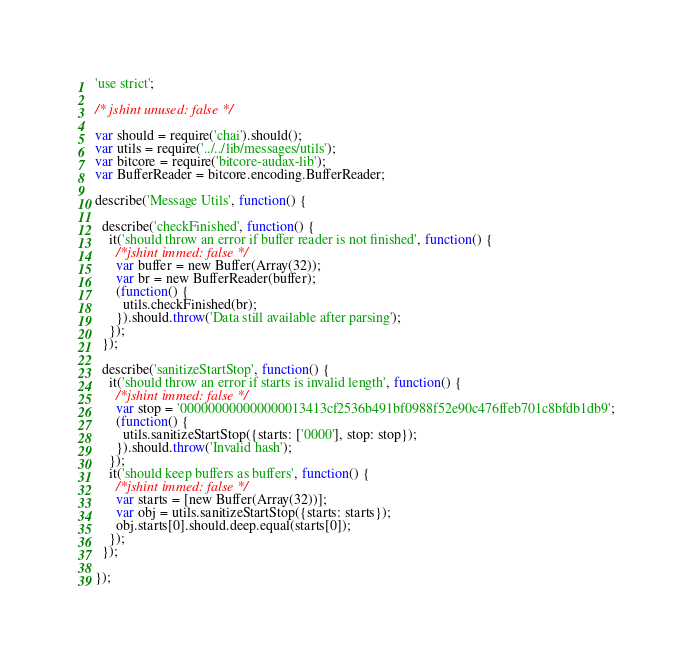Convert code to text. <code><loc_0><loc_0><loc_500><loc_500><_JavaScript_>'use strict';

/* jshint unused: false */

var should = require('chai').should();
var utils = require('../../lib/messages/utils');
var bitcore = require('bitcore-audax-lib');
var BufferReader = bitcore.encoding.BufferReader;

describe('Message Utils', function() {

  describe('checkFinished', function() {
    it('should throw an error if buffer reader is not finished', function() {
      /*jshint immed: false */
      var buffer = new Buffer(Array(32));
      var br = new BufferReader(buffer);
      (function() {
        utils.checkFinished(br);
      }).should.throw('Data still available after parsing');
    });
  });

  describe('sanitizeStartStop', function() {
    it('should throw an error if starts is invalid length', function() {
      /*jshint immed: false */
      var stop = '000000000000000013413cf2536b491bf0988f52e90c476ffeb701c8bfdb1db9';
      (function() {
        utils.sanitizeStartStop({starts: ['0000'], stop: stop});
      }).should.throw('Invalid hash');
    });
    it('should keep buffers as buffers', function() {
      /*jshint immed: false */
      var starts = [new Buffer(Array(32))];
      var obj = utils.sanitizeStartStop({starts: starts});
      obj.starts[0].should.deep.equal(starts[0]);
    });
  });

});
</code> 